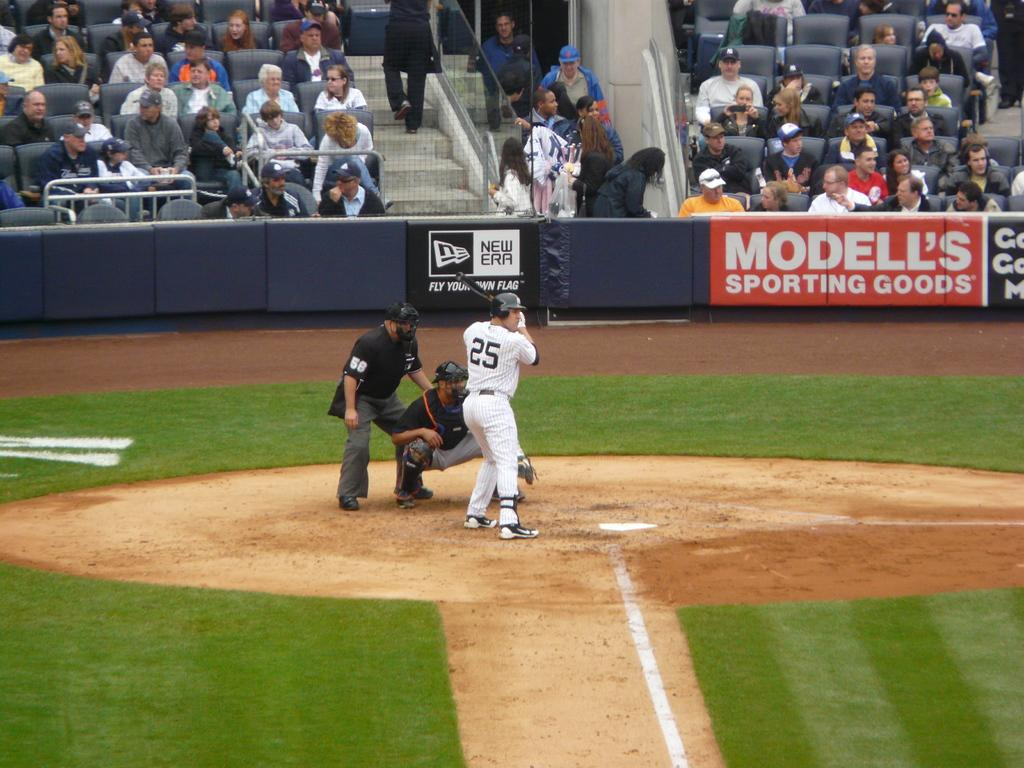<image>
Create a compact narrative representing the image presented. A batter, number 25 is waiting for the pitch in the baseball game with a sign advertising Modell's Sporting Goods to the right. 